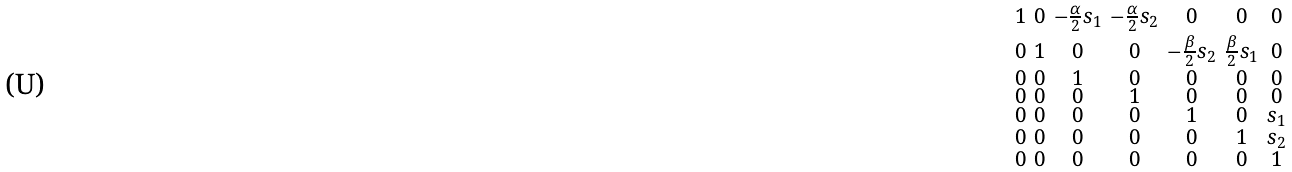<formula> <loc_0><loc_0><loc_500><loc_500>\begin{smallmatrix} 1 & 0 & - \frac { \alpha } { 2 } s _ { 1 } & - \frac { \alpha } { 2 } s _ { 2 } & 0 & 0 & 0 \\ 0 & 1 & 0 & 0 & - \frac { \beta } { 2 } s _ { 2 } & \frac { \beta } { 2 } s _ { 1 } & 0 \\ 0 & 0 & 1 & 0 & 0 & 0 & 0 \\ 0 & 0 & 0 & 1 & 0 & 0 & 0 \\ 0 & 0 & 0 & 0 & 1 & 0 & s _ { 1 } \\ 0 & 0 & 0 & 0 & 0 & 1 & s _ { 2 } \\ 0 & 0 & 0 & 0 & 0 & 0 & 1 \end{smallmatrix}</formula> 